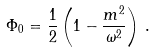Convert formula to latex. <formula><loc_0><loc_0><loc_500><loc_500>\Phi _ { 0 } = \frac { 1 } { 2 } \left ( 1 - \frac { m ^ { 2 } } { \omega ^ { 2 } } \right ) \, .</formula> 